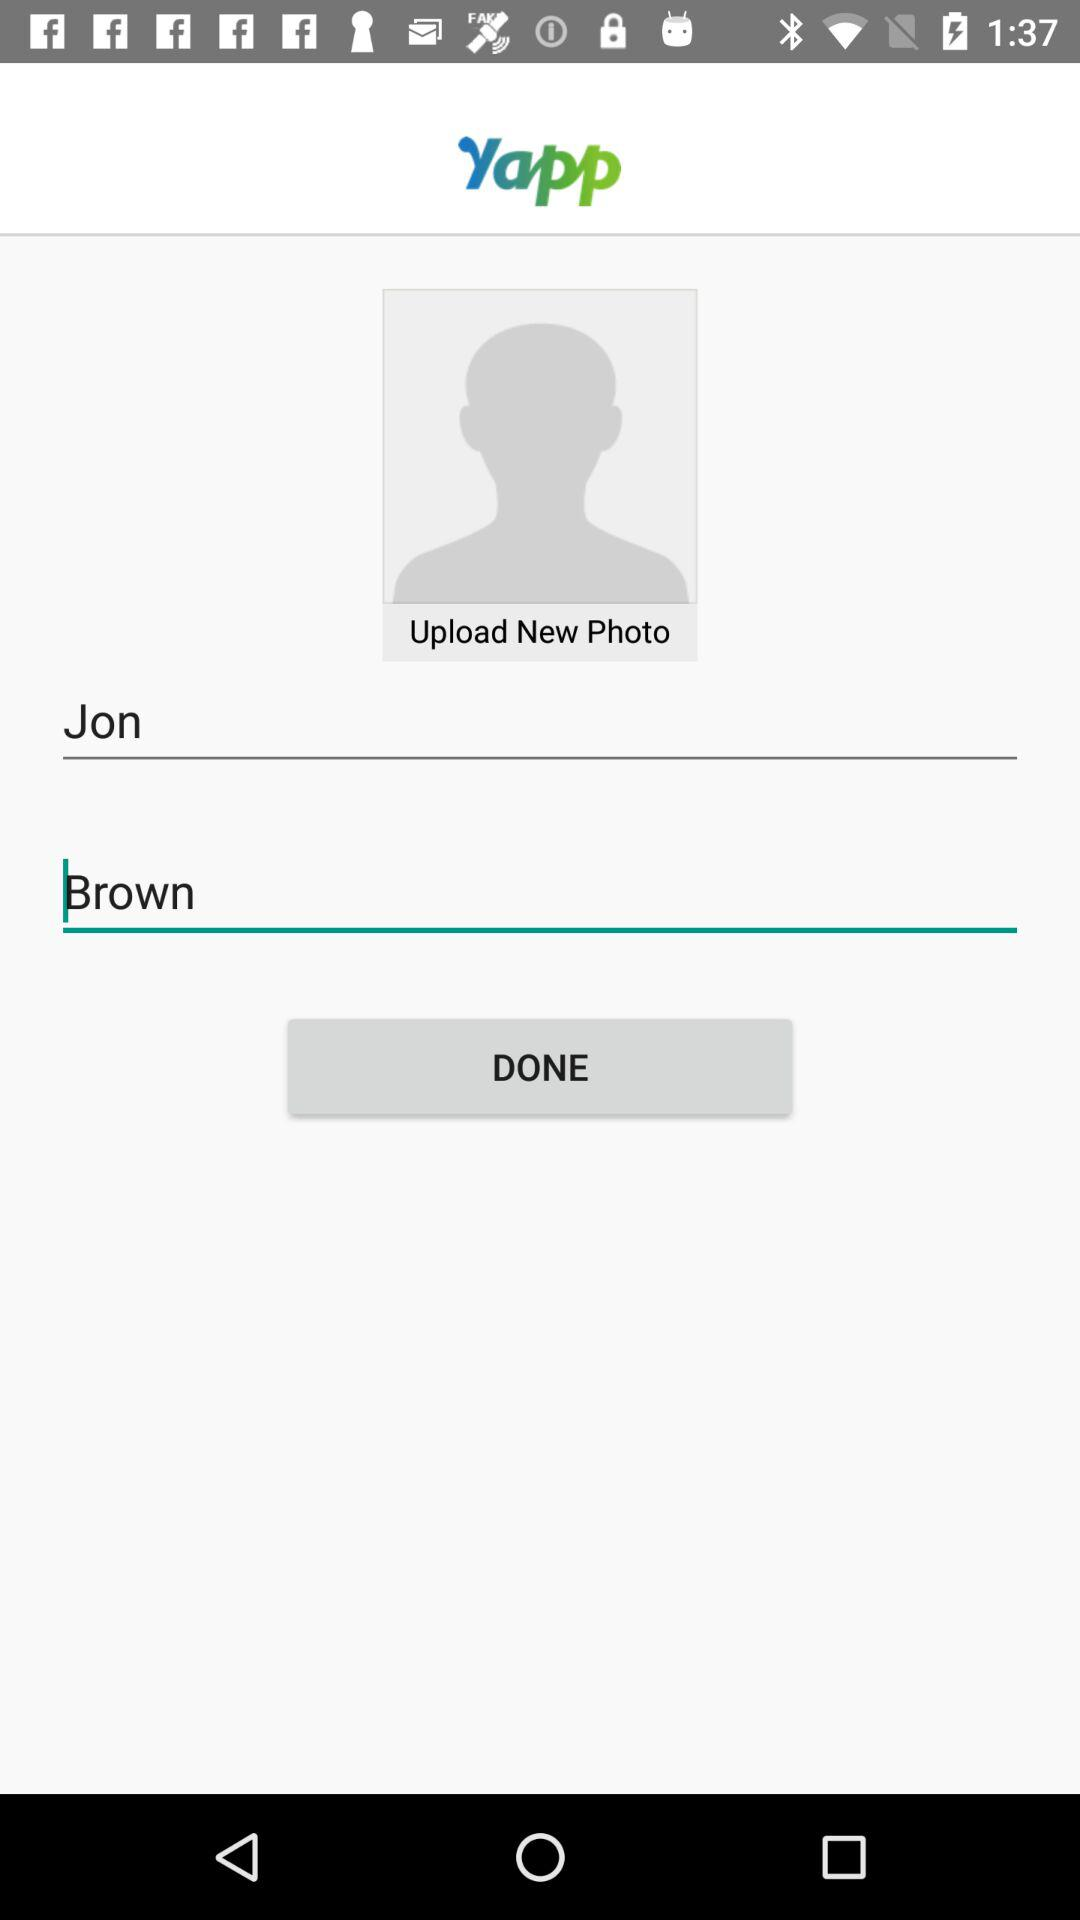What is the given first name? The given first name is Jon. 